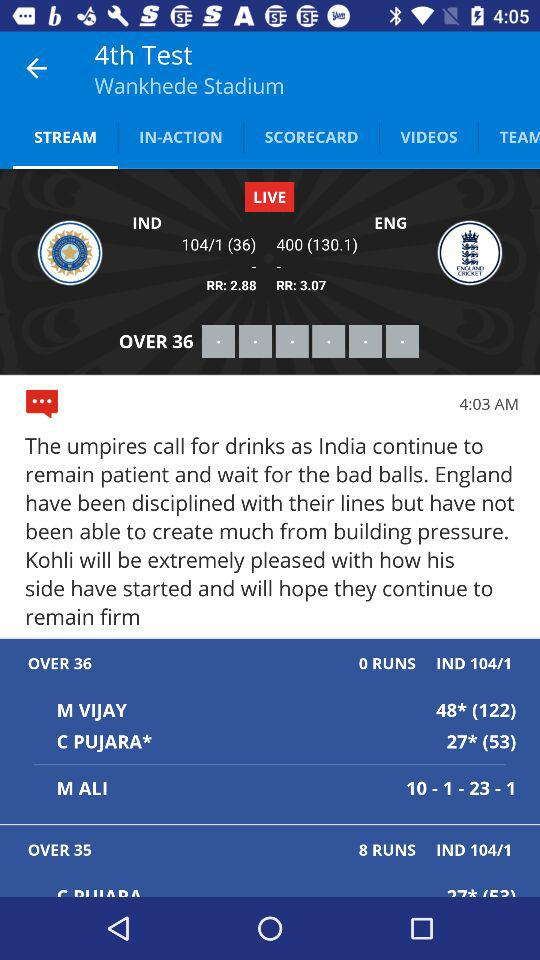How many wickets does India have?
Answer the question using a single word or phrase. 1 